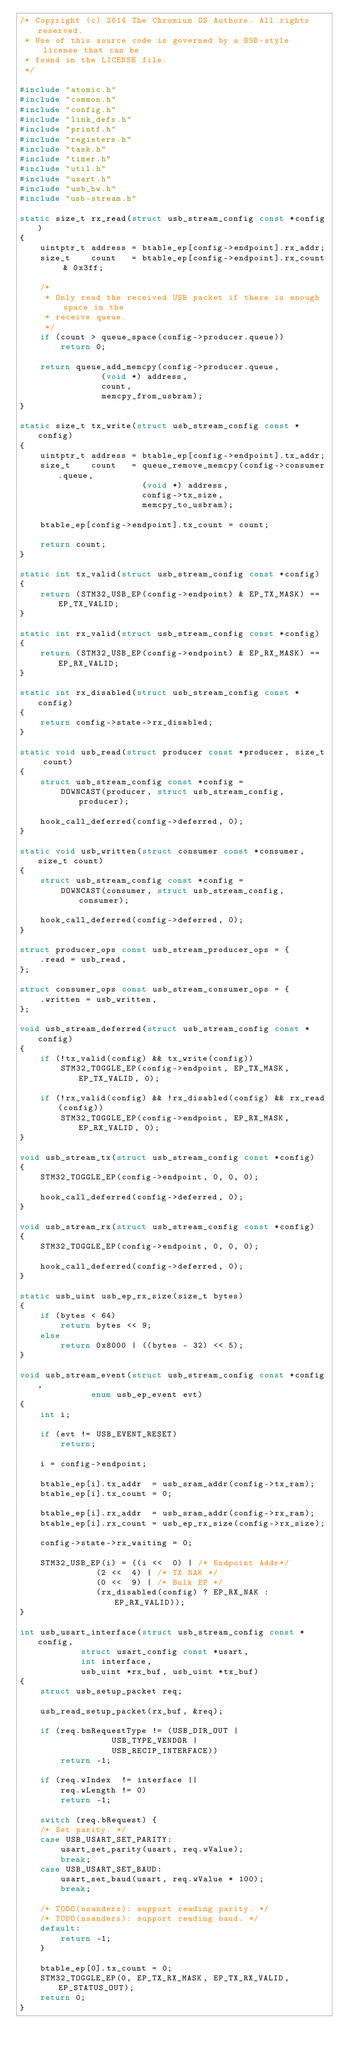Convert code to text. <code><loc_0><loc_0><loc_500><loc_500><_C_>/* Copyright (c) 2014 The Chromium OS Authors. All rights reserved.
 * Use of this source code is governed by a BSD-style license that can be
 * found in the LICENSE file.
 */

#include "atomic.h"
#include "common.h"
#include "config.h"
#include "link_defs.h"
#include "printf.h"
#include "registers.h"
#include "task.h"
#include "timer.h"
#include "util.h"
#include "usart.h"
#include "usb_hw.h"
#include "usb-stream.h"

static size_t rx_read(struct usb_stream_config const *config)
{
	uintptr_t address = btable_ep[config->endpoint].rx_addr;
	size_t    count   = btable_ep[config->endpoint].rx_count & 0x3ff;

	/*
	 * Only read the received USB packet if there is enough space in the
	 * receive queue.
	 */
	if (count > queue_space(config->producer.queue))
		return 0;

	return queue_add_memcpy(config->producer.queue,
				(void *) address,
				count,
				memcpy_from_usbram);
}

static size_t tx_write(struct usb_stream_config const *config)
{
	uintptr_t address = btable_ep[config->endpoint].tx_addr;
	size_t    count   = queue_remove_memcpy(config->consumer.queue,
						(void *) address,
						config->tx_size,
						memcpy_to_usbram);

	btable_ep[config->endpoint].tx_count = count;

	return count;
}

static int tx_valid(struct usb_stream_config const *config)
{
	return (STM32_USB_EP(config->endpoint) & EP_TX_MASK) == EP_TX_VALID;
}

static int rx_valid(struct usb_stream_config const *config)
{
	return (STM32_USB_EP(config->endpoint) & EP_RX_MASK) == EP_RX_VALID;
}

static int rx_disabled(struct usb_stream_config const *config)
{
	return config->state->rx_disabled;
}

static void usb_read(struct producer const *producer, size_t count)
{
	struct usb_stream_config const *config =
		DOWNCAST(producer, struct usb_stream_config, producer);

	hook_call_deferred(config->deferred, 0);
}

static void usb_written(struct consumer const *consumer, size_t count)
{
	struct usb_stream_config const *config =
		DOWNCAST(consumer, struct usb_stream_config, consumer);

	hook_call_deferred(config->deferred, 0);
}

struct producer_ops const usb_stream_producer_ops = {
	.read = usb_read,
};

struct consumer_ops const usb_stream_consumer_ops = {
	.written = usb_written,
};

void usb_stream_deferred(struct usb_stream_config const *config)
{
	if (!tx_valid(config) && tx_write(config))
		STM32_TOGGLE_EP(config->endpoint, EP_TX_MASK, EP_TX_VALID, 0);

	if (!rx_valid(config) && !rx_disabled(config) && rx_read(config))
		STM32_TOGGLE_EP(config->endpoint, EP_RX_MASK, EP_RX_VALID, 0);
}

void usb_stream_tx(struct usb_stream_config const *config)
{
	STM32_TOGGLE_EP(config->endpoint, 0, 0, 0);

	hook_call_deferred(config->deferred, 0);
}

void usb_stream_rx(struct usb_stream_config const *config)
{
	STM32_TOGGLE_EP(config->endpoint, 0, 0, 0);

	hook_call_deferred(config->deferred, 0);
}

static usb_uint usb_ep_rx_size(size_t bytes)
{
	if (bytes < 64)
		return bytes << 9;
	else
		return 0x8000 | ((bytes - 32) << 5);
}

void usb_stream_event(struct usb_stream_config const *config,
		      enum usb_ep_event evt)
{
	int i;

	if (evt != USB_EVENT_RESET)
		return;

	i = config->endpoint;

	btable_ep[i].tx_addr  = usb_sram_addr(config->tx_ram);
	btable_ep[i].tx_count = 0;

	btable_ep[i].rx_addr  = usb_sram_addr(config->rx_ram);
	btable_ep[i].rx_count = usb_ep_rx_size(config->rx_size);

	config->state->rx_waiting = 0;

	STM32_USB_EP(i) = ((i <<  0) | /* Endpoint Addr*/
			   (2 <<  4) | /* TX NAK */
			   (0 <<  9) | /* Bulk EP */
			   (rx_disabled(config) ? EP_RX_NAK : EP_RX_VALID));
}

int usb_usart_interface(struct usb_stream_config const *config,
			struct usart_config const *usart,
			int interface,
			usb_uint *rx_buf, usb_uint *tx_buf)
{
	struct usb_setup_packet req;

	usb_read_setup_packet(rx_buf, &req);

	if (req.bmRequestType != (USB_DIR_OUT |
				  USB_TYPE_VENDOR |
				  USB_RECIP_INTERFACE))
		return -1;

	if (req.wIndex  != interface ||
	    req.wLength != 0)
		return -1;

	switch (req.bRequest) {
	/* Set parity. */
	case USB_USART_SET_PARITY:
		usart_set_parity(usart, req.wValue);
		break;
	case USB_USART_SET_BAUD:
		usart_set_baud(usart, req.wValue * 100);
		break;

	/* TODO(nsanders): support reading parity. */
	/* TODO(nsanders): support reading baud. */
	default:
		return -1;
	}

	btable_ep[0].tx_count = 0;
	STM32_TOGGLE_EP(0, EP_TX_RX_MASK, EP_TX_RX_VALID, EP_STATUS_OUT);
	return 0;
}
</code> 